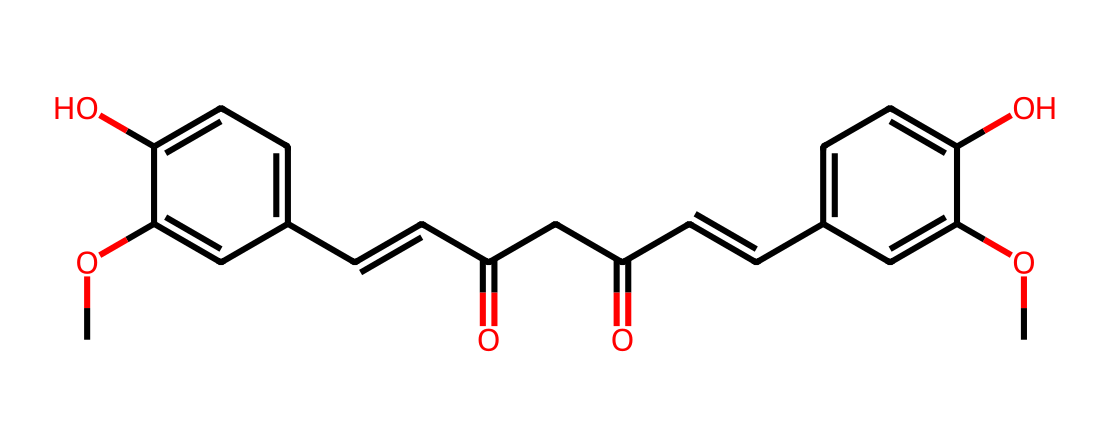What is the name of this chemical compound? The provided SMILES structure represents curcumin, which is the major bioactive component found in turmeric.
Answer: curcumin How many hydroxyl (-OH) groups are present in this structure? By analyzing the structure, we can identify two hydroxyl groups. They can be seen on the aromatic rings attached as -OH functional groups.
Answer: two What is the total number of carbon atoms in curcumin's structure? Counting the carbon atoms in the SMILES representation gives a total of 21 carbon atoms. Each carbon in the structure contributes to the overall count.
Answer: 21 What kind of functional groups are present in curcumin? Curcumin contains hydroxyl groups (-OH) and carbonyl groups (C=O), contributing to its antioxidant properties.
Answer: hydroxyl and carbonyl How does the presence of multiple double bonds affect curcumin? The presence of multiple double bonds, specifically in the conjugated carbon chain (the C=C), enhances its antioxidant activity by allowing it to stabilize free radicals through electron delocalization.
Answer: enhances antioxidant activity What role does curcumin play in health, specifically related to antioxidants? As an antioxidant, curcumin helps neutralize free radicals and reduce oxidative stress in the body, contributing to various health benefits.
Answer: antioxidant 